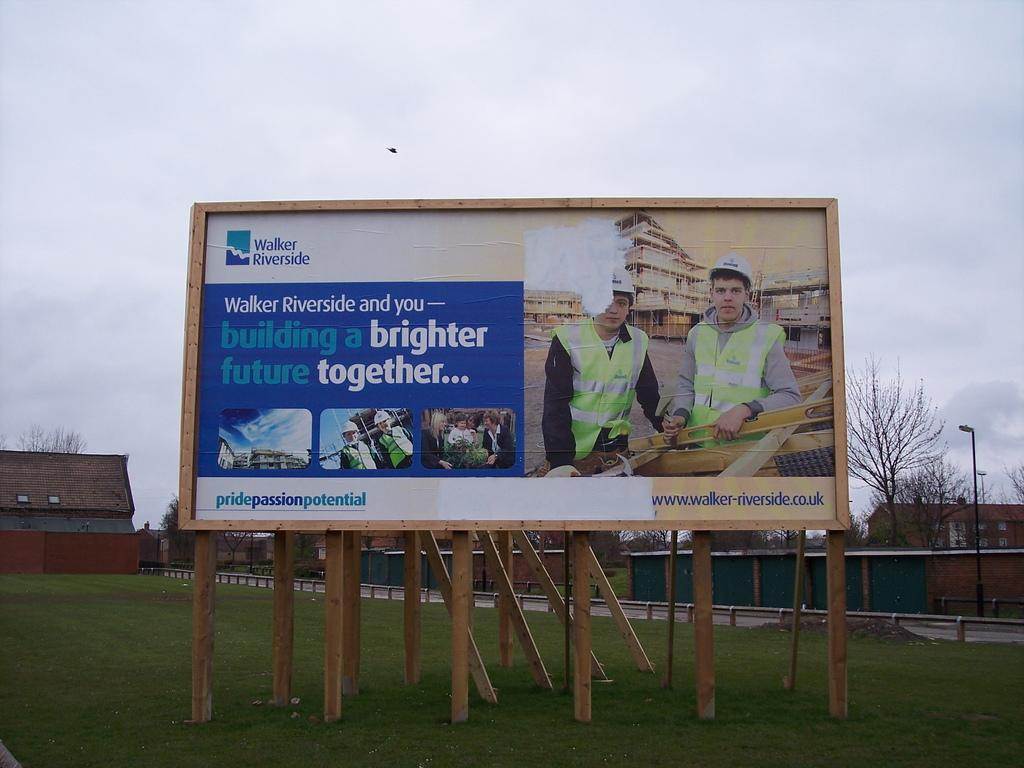<image>
Create a compact narrative representing the image presented. A large billboard for Walker Riverside featuring construction workers is in a field. 